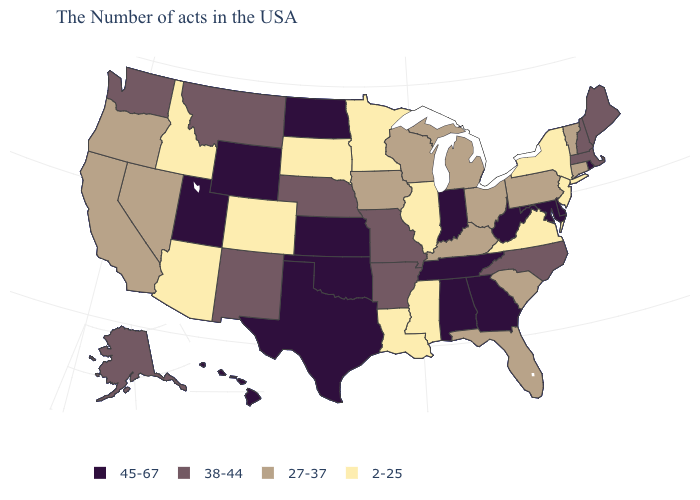Name the states that have a value in the range 45-67?
Quick response, please. Rhode Island, Delaware, Maryland, West Virginia, Georgia, Indiana, Alabama, Tennessee, Kansas, Oklahoma, Texas, North Dakota, Wyoming, Utah, Hawaii. What is the value of Illinois?
Be succinct. 2-25. What is the lowest value in the USA?
Answer briefly. 2-25. What is the lowest value in the USA?
Be succinct. 2-25. What is the highest value in states that border Florida?
Concise answer only. 45-67. Does Illinois have the lowest value in the USA?
Quick response, please. Yes. Does the first symbol in the legend represent the smallest category?
Answer briefly. No. What is the value of Delaware?
Short answer required. 45-67. What is the lowest value in the USA?
Concise answer only. 2-25. Which states have the lowest value in the Northeast?
Short answer required. New York, New Jersey. What is the value of Ohio?
Short answer required. 27-37. Name the states that have a value in the range 38-44?
Write a very short answer. Maine, Massachusetts, New Hampshire, North Carolina, Missouri, Arkansas, Nebraska, New Mexico, Montana, Washington, Alaska. Which states have the lowest value in the USA?
Short answer required. New York, New Jersey, Virginia, Illinois, Mississippi, Louisiana, Minnesota, South Dakota, Colorado, Arizona, Idaho. What is the highest value in the Northeast ?
Short answer required. 45-67. 